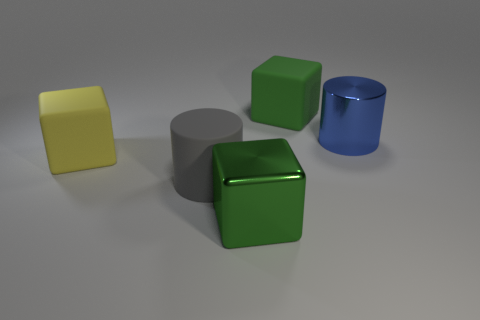There is a rubber block that is the same color as the shiny block; what size is it?
Your response must be concise. Large. There is a large shiny cylinder; is it the same color as the large rubber thing behind the big blue cylinder?
Ensure brevity in your answer.  No. There is a blue shiny object; are there any big blue metal cylinders in front of it?
Provide a succinct answer. No. There is a matte object on the right side of the big gray cylinder; is its size the same as the thing that is left of the big gray matte thing?
Offer a very short reply. Yes. Are there any yellow metal objects that have the same size as the blue object?
Offer a terse response. No. There is a big thing that is to the left of the large gray object; does it have the same shape as the blue thing?
Make the answer very short. No. What is the thing in front of the gray matte object made of?
Offer a very short reply. Metal. What is the shape of the rubber thing right of the big green object in front of the large rubber cylinder?
Keep it short and to the point. Cube. Is the shape of the green matte object the same as the metal thing that is behind the yellow rubber block?
Give a very brief answer. No. There is a shiny object that is in front of the gray cylinder; what number of green metallic objects are in front of it?
Your response must be concise. 0. 